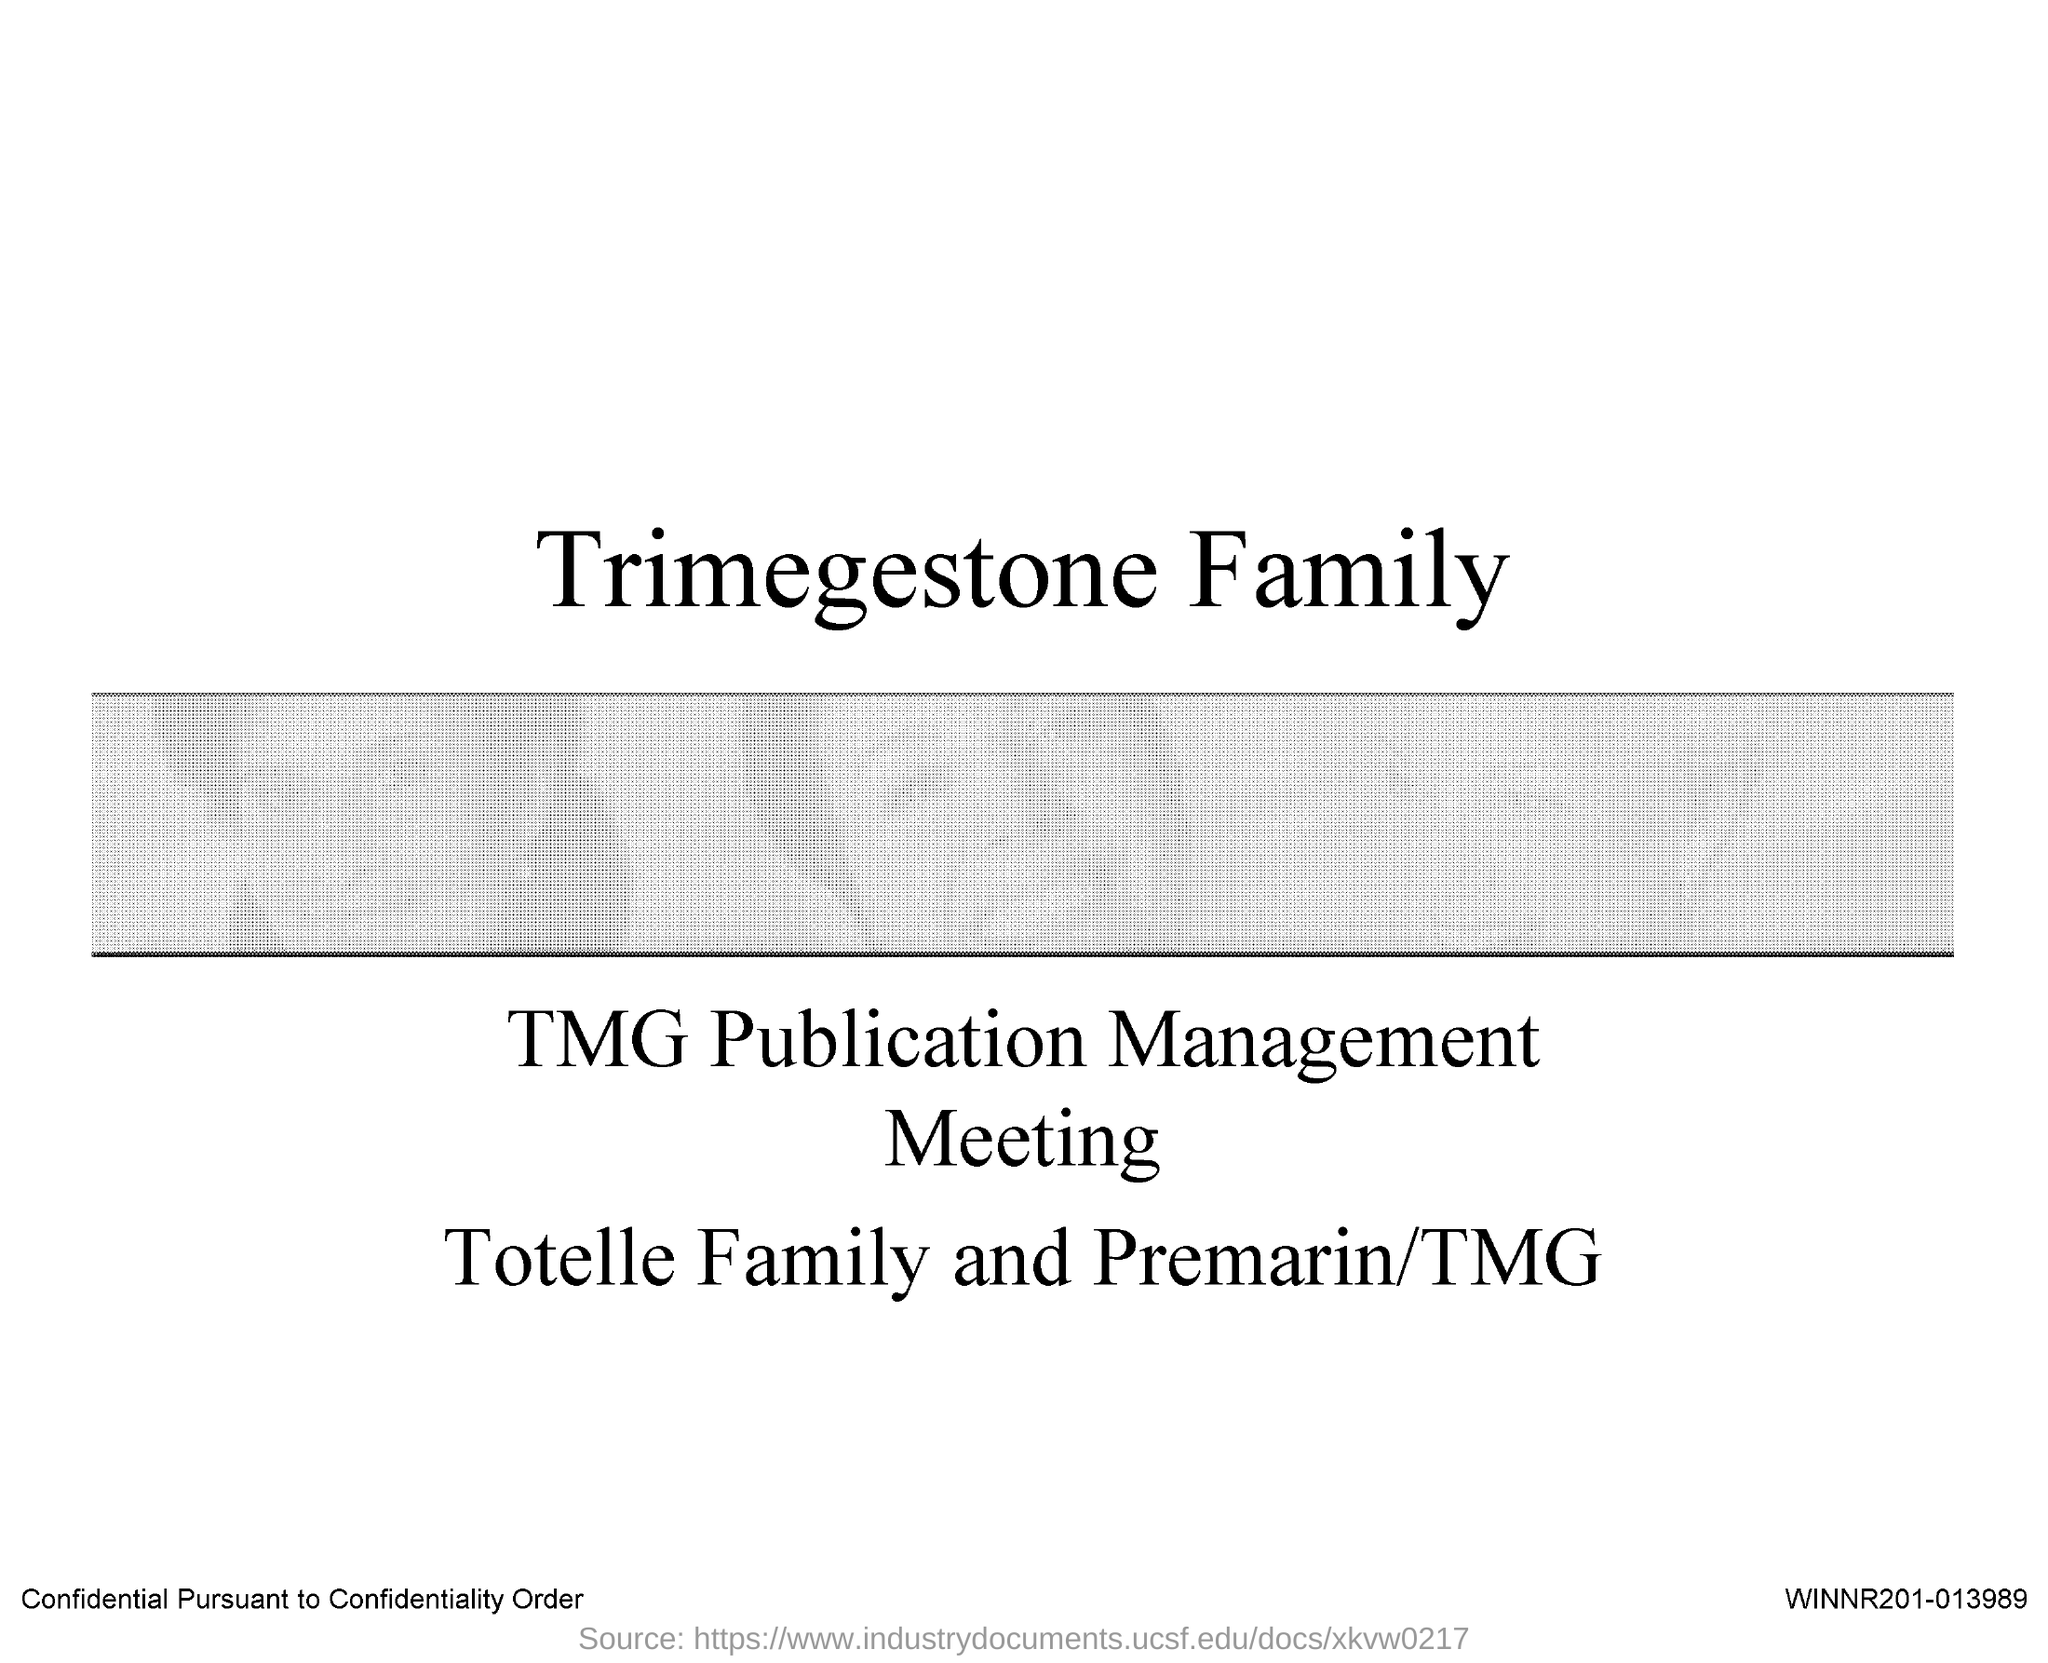Indicate a few pertinent items in this graphic. The document in question is titled "Trimegestone Family. 